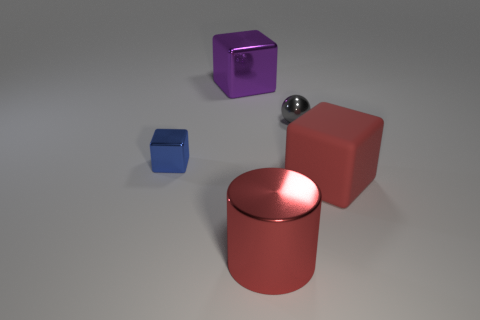Subtract all shiny cubes. How many cubes are left? 1 Add 4 blue things. How many blue things are left? 5 Add 1 purple shiny blocks. How many purple shiny blocks exist? 2 Add 5 tiny objects. How many objects exist? 10 Subtract all blue cubes. How many cubes are left? 2 Subtract 0 brown balls. How many objects are left? 5 Subtract all cylinders. How many objects are left? 4 Subtract all brown cylinders. Subtract all green spheres. How many cylinders are left? 1 Subtract all blue balls. How many red cubes are left? 1 Subtract all tiny yellow matte objects. Subtract all gray shiny things. How many objects are left? 4 